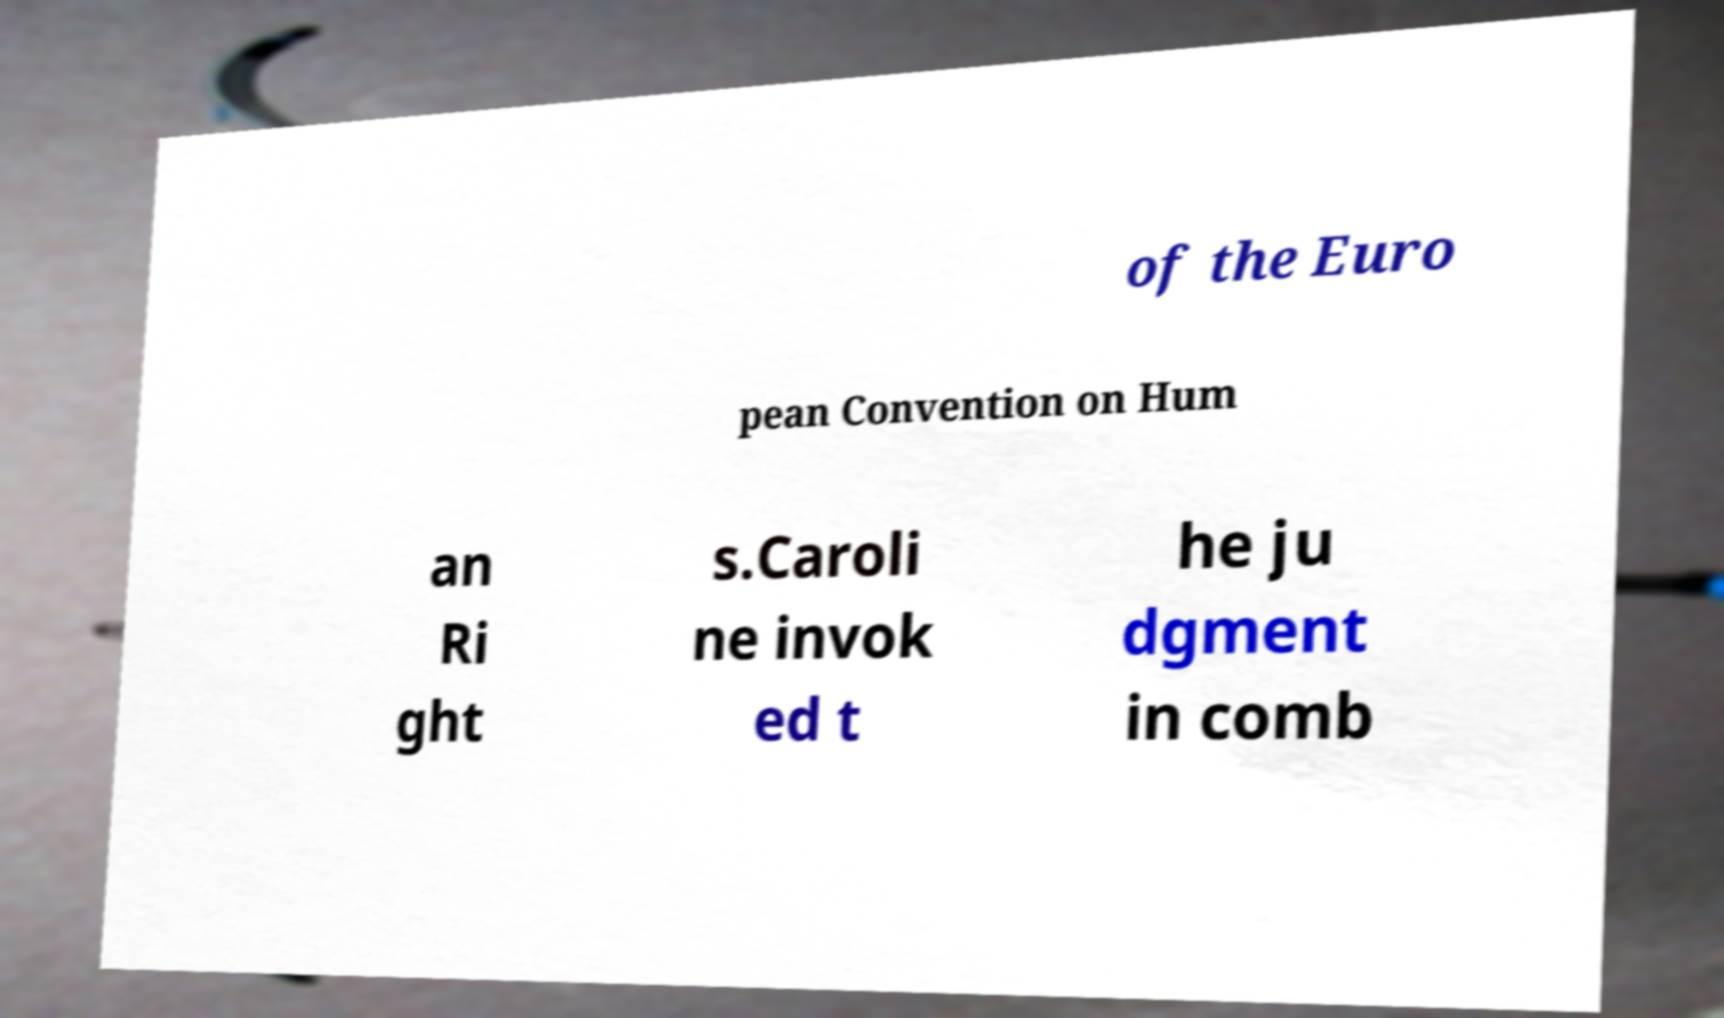Can you accurately transcribe the text from the provided image for me? of the Euro pean Convention on Hum an Ri ght s.Caroli ne invok ed t he ju dgment in comb 